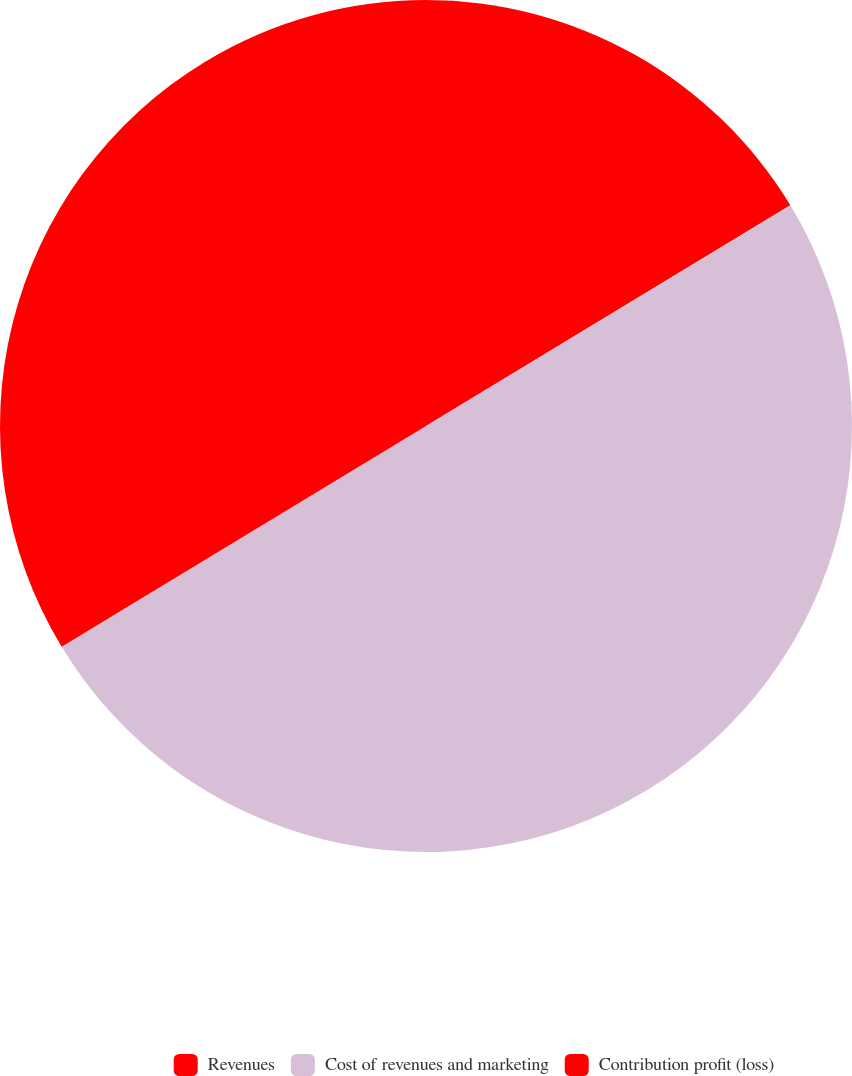Convert chart to OTSL. <chart><loc_0><loc_0><loc_500><loc_500><pie_chart><fcel>Revenues<fcel>Cost of revenues and marketing<fcel>Contribution profit (loss)<nl><fcel>16.33%<fcel>50.0%<fcel>33.67%<nl></chart> 